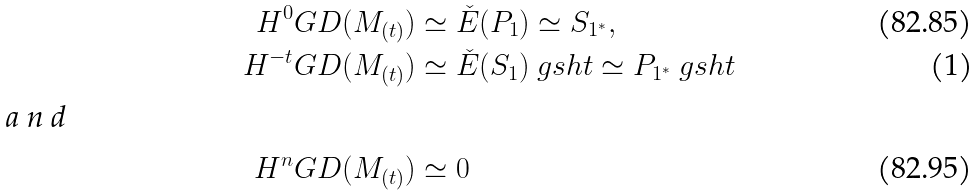Convert formula to latex. <formula><loc_0><loc_0><loc_500><loc_500>H ^ { 0 } G D ( M _ { ( t ) } ) & \simeq \check { E } ( P _ { 1 } ) \simeq S _ { 1 ^ { \ast } } , \\ H ^ { - t } G D ( M _ { ( t ) } ) & \simeq \check { E } ( S _ { 1 } ) \ g s h t \simeq P _ { 1 ^ { \ast } } \ g s h t \intertext { a n d } H ^ { n } G D ( M _ { ( t ) } ) & \simeq 0</formula> 